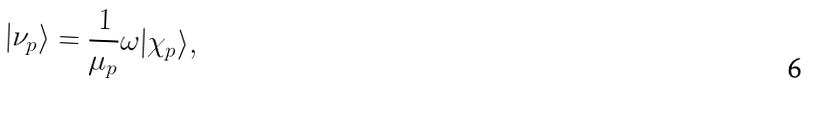<formula> <loc_0><loc_0><loc_500><loc_500>| \nu _ { p } \rangle = \frac { 1 } { \mu _ { p } } \omega | \chi _ { p } \rangle ,</formula> 